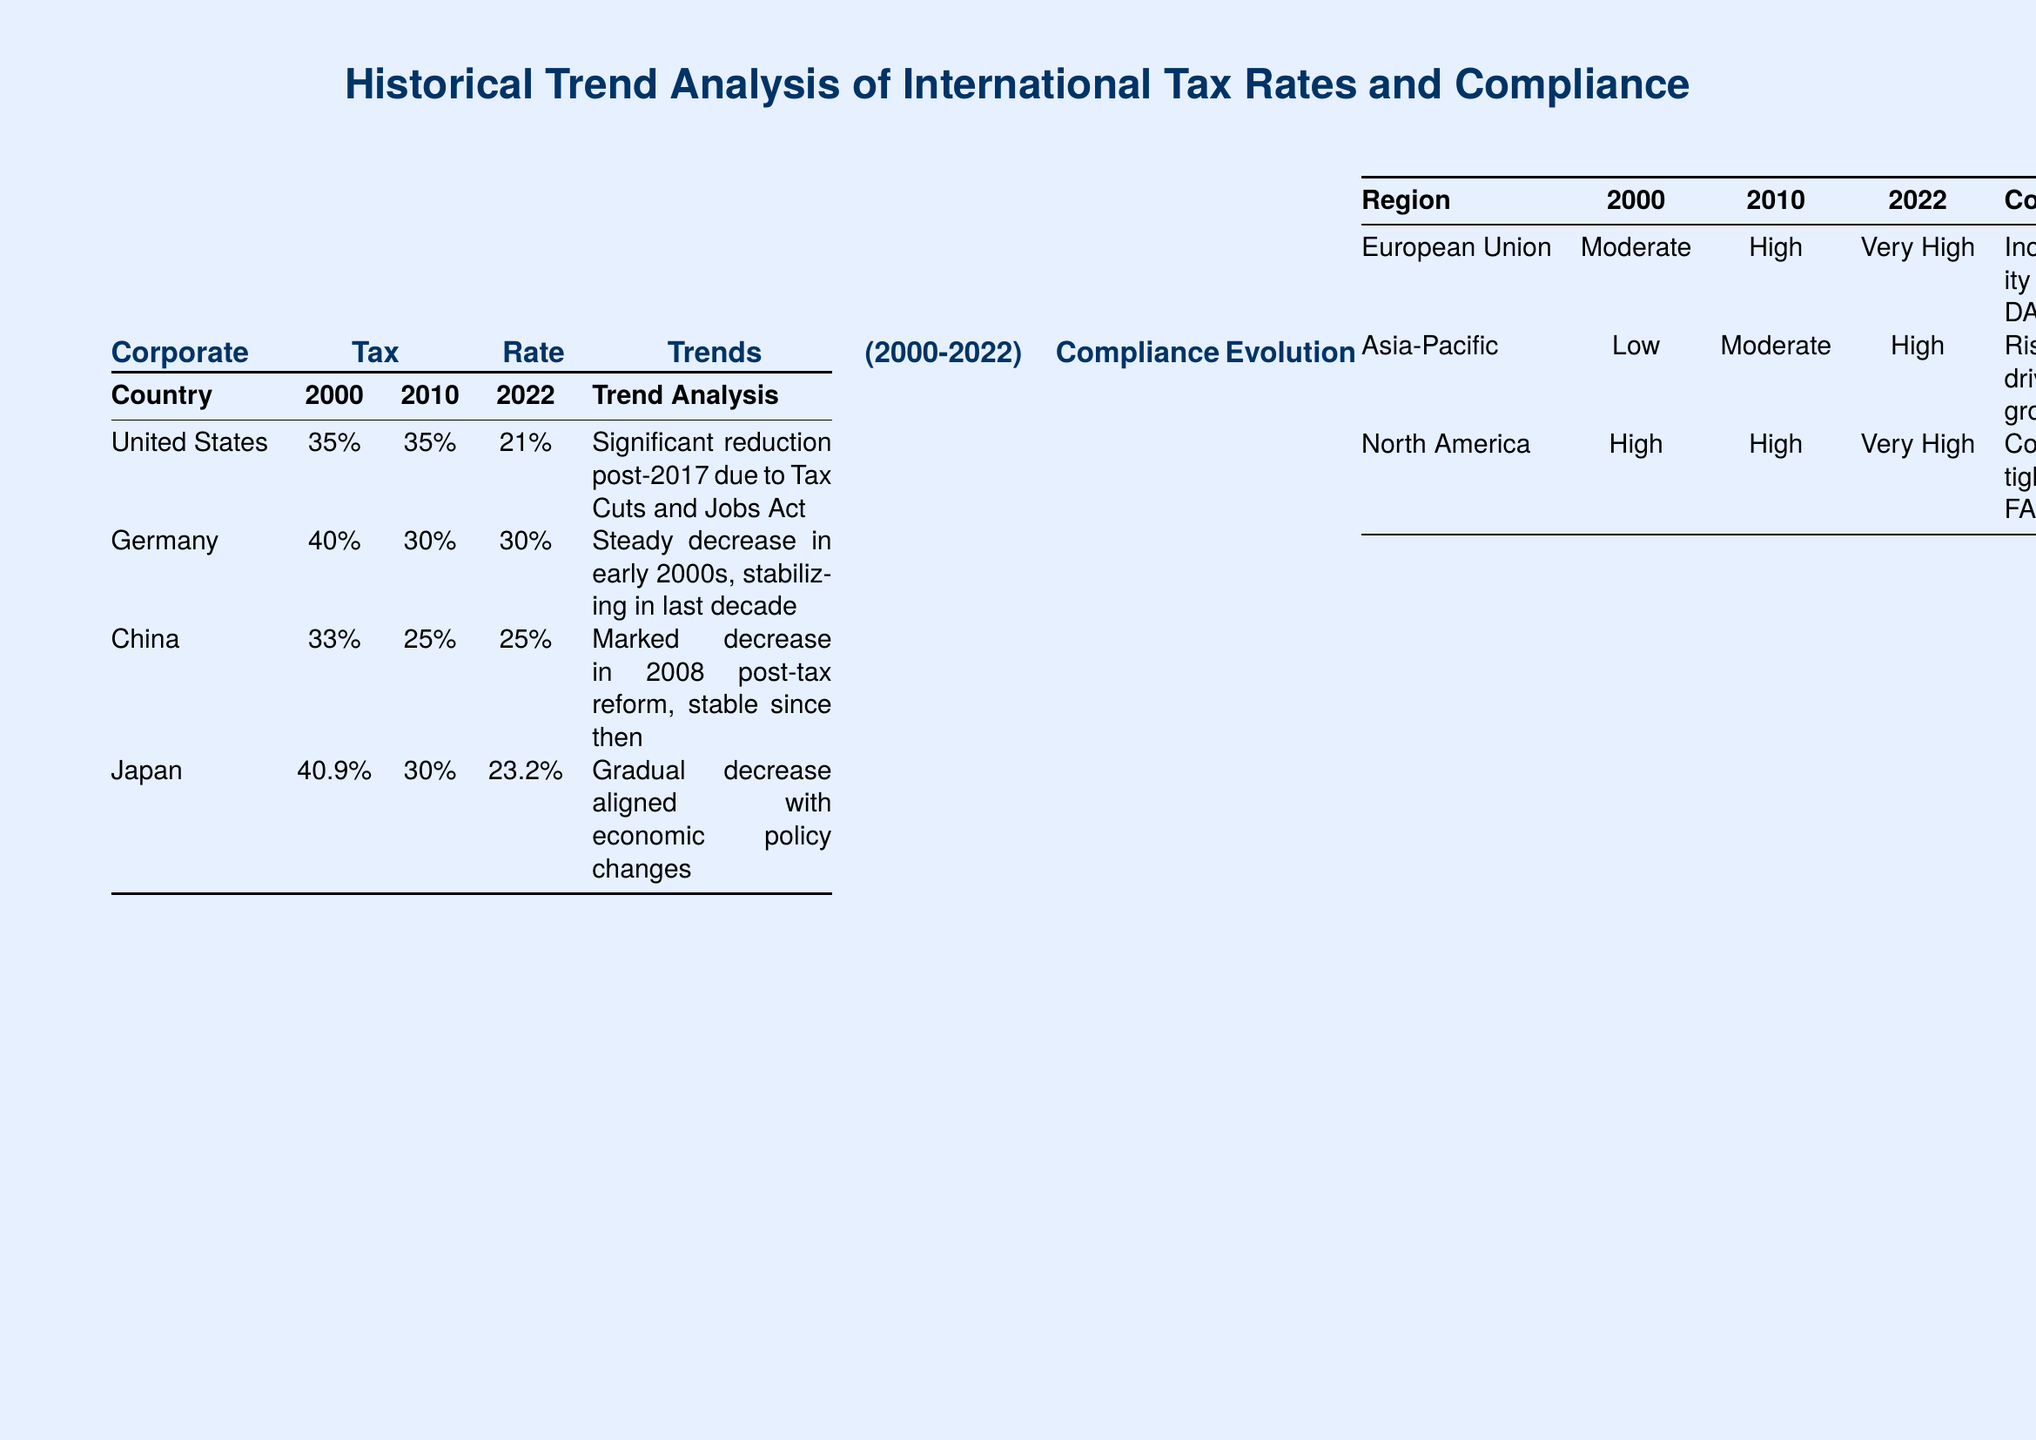What was the corporate tax rate for the United States in 2000? The document states that the corporate tax rate for the United States in 2000 was 35%.
Answer: 35% Which country saw a significant reduction in corporate tax rates post-2017? The document specifies that the United States experienced a significant reduction in corporate tax rates post-2017.
Answer: United States What was the compliance status of the Asia-Pacific region in 2022? The document indicates that the compliance status of the Asia-Pacific region in 2022 was High.
Answer: High What was the average GDP growth for Ireland during the key years mentioned? The document shows that Ireland had an average GDP growth of 5.5% annually.
Answer: 5.5% What compliance strategy has a high effectiveness rating? The document lists Automated Reporting as a strategy with high effectiveness.
Answer: Automated Reporting What was the corporate tax rate in Japan in 2010? The document states that the corporate tax rate in Japan in 2010 was 30%.
Answer: 30% What trend is noted for Germany's corporate tax rates? The document notes a steady decrease in Germany's corporate tax rates in the early 2000s, stabilizing in the last decade.
Answer: Steady decrease What year showed a marked decrease in China's corporate tax rate? The document indicates that a marked decrease in China's corporate tax rate occurred in 2008.
Answer: 2008 What is the compliance status of North America in 2022? The document shows that the compliance status of North America in 2022 was Very High.
Answer: Very High 